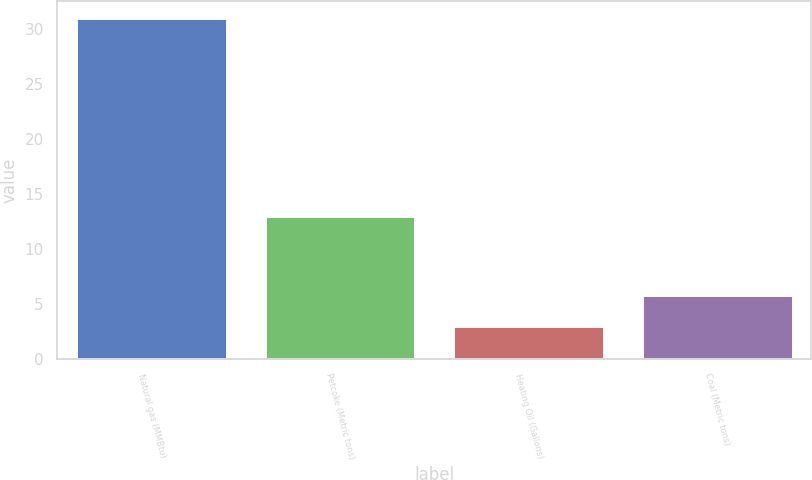Convert chart. <chart><loc_0><loc_0><loc_500><loc_500><bar_chart><fcel>Natural gas (MMBtu)<fcel>Petcoke (Metric tons)<fcel>Heating Oil (Gallons)<fcel>Coal (Metric tons)<nl><fcel>31<fcel>13<fcel>3<fcel>5.8<nl></chart> 